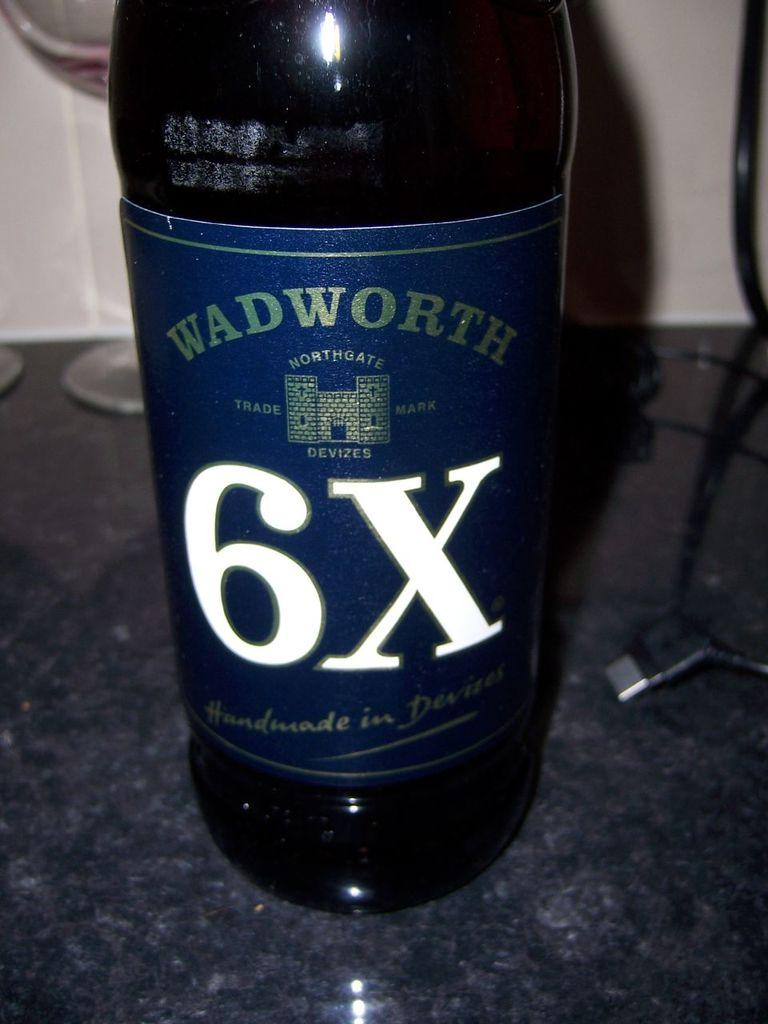Provide a one-sentence caption for the provided image. A bottle of WADWORTH 6X sits on a table with a phone charger. 